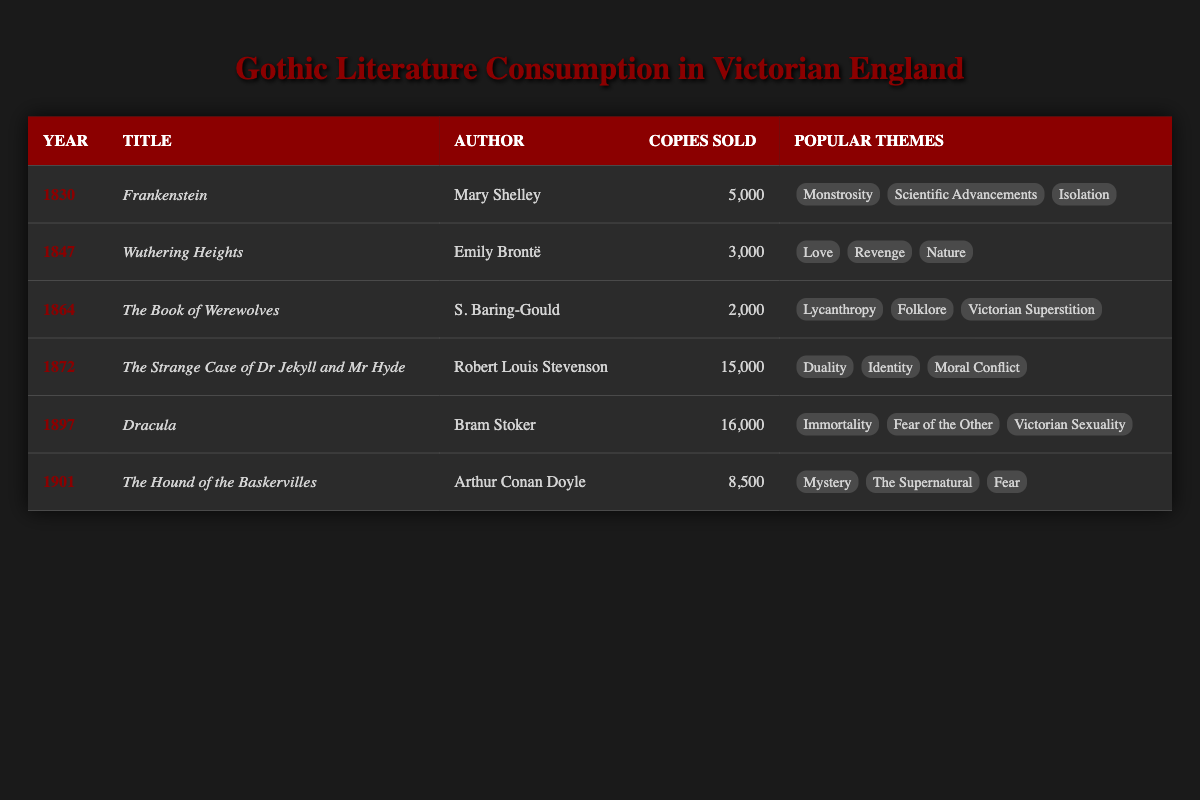What year was "Dracula" published? The table indicates that "Dracula" was published in the year 1897.
Answer: 1897 Which book had the highest number of copies sold? By examining the "Copies Sold" column, "Dracula" has the highest at 16,000 copies.
Answer: Dracula What are the popular themes of "The Strange Case of Dr Jekyll and Mr Hyde"? According to the table, the popular themes for this book include Duality, Identity, and Moral Conflict.
Answer: Duality, Identity, Moral Conflict What is the average number of copies sold for the Gothic literature listed? To find the average, sum the copies sold: 5,000 + 3,000 + 2,000 + 15,000 + 16,000 + 8,500 = 49,500. There are 6 books, so the average is 49,500 / 6 = 8,250.
Answer: 8,250 Did any authors sell more than 10,000 copies of their books? Yes, both "Dr Jekyll and Mr Hyde" and "Dracula" sold more than 10,000 copies.
Answer: Yes Which themes are common between "Frankenstein" and "Wuthering Heights"? There are no common themes listed for "Frankenstein" and "Wuthering Heights" as they address entirely different topics; thus, "No" is the answer.
Answer: No What is the total number of copies sold for books published before 1870? The books published before 1870 are "Frankenstein" (5,000), "Wuthering Heights" (3,000), and "The Book of Werewolves" (2,000). Summing these gives 5,000 + 3,000 + 2,000 = 10,000 copies sold.
Answer: 10,000 Which author had the most themes mentioned for their book? "Dracula" by Bram Stoker has three popular themes: Immortality, Fear of the Other, and Victorian Sexuality, which matches with others but isn't less than others on the overall number.
Answer: Bram Stoker 